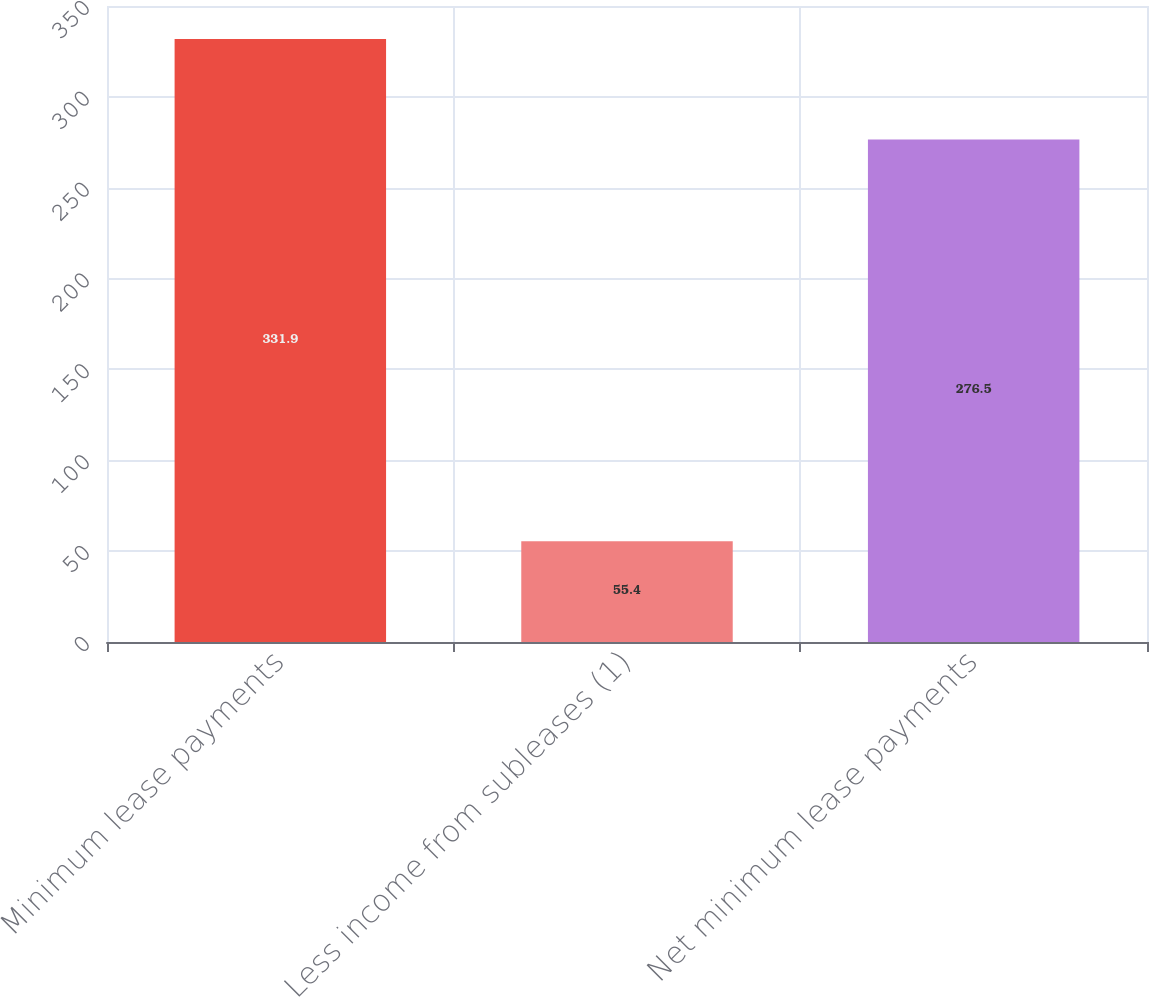Convert chart to OTSL. <chart><loc_0><loc_0><loc_500><loc_500><bar_chart><fcel>Minimum lease payments<fcel>Less income from subleases (1)<fcel>Net minimum lease payments<nl><fcel>331.9<fcel>55.4<fcel>276.5<nl></chart> 